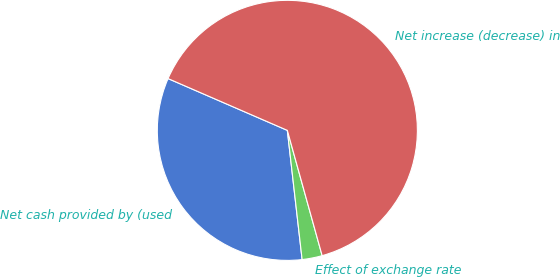Convert chart. <chart><loc_0><loc_0><loc_500><loc_500><pie_chart><fcel>Net cash provided by (used<fcel>Effect of exchange rate<fcel>Net increase (decrease) in<nl><fcel>33.33%<fcel>2.5%<fcel>64.16%<nl></chart> 